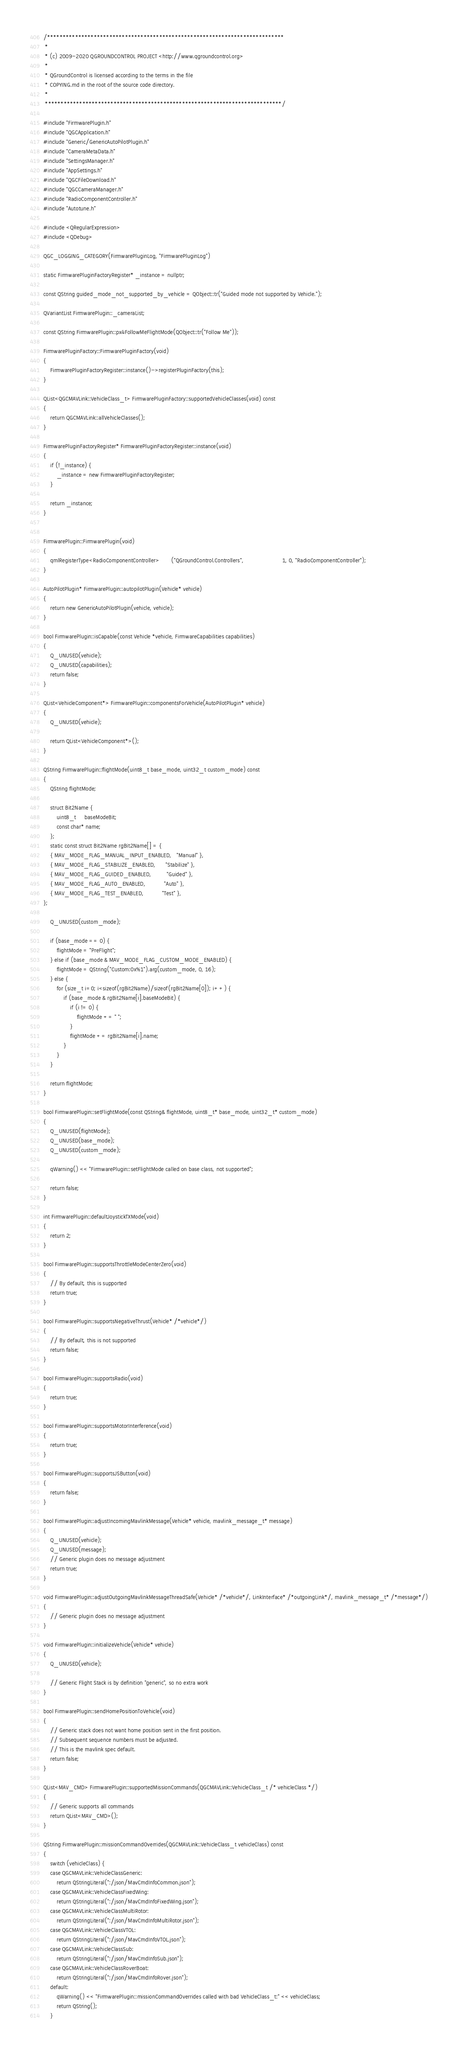Convert code to text. <code><loc_0><loc_0><loc_500><loc_500><_C++_>/****************************************************************************
 *
 * (c) 2009-2020 QGROUNDCONTROL PROJECT <http://www.qgroundcontrol.org>
 *
 * QGroundControl is licensed according to the terms in the file
 * COPYING.md in the root of the source code directory.
 *
 ****************************************************************************/

#include "FirmwarePlugin.h"
#include "QGCApplication.h"
#include "Generic/GenericAutoPilotPlugin.h"
#include "CameraMetaData.h"
#include "SettingsManager.h"
#include "AppSettings.h"
#include "QGCFileDownload.h"
#include "QGCCameraManager.h"
#include "RadioComponentController.h"
#include "Autotune.h"

#include <QRegularExpression>
#include <QDebug>

QGC_LOGGING_CATEGORY(FirmwarePluginLog, "FirmwarePluginLog")

static FirmwarePluginFactoryRegister* _instance = nullptr;

const QString guided_mode_not_supported_by_vehicle = QObject::tr("Guided mode not supported by Vehicle.");

QVariantList FirmwarePlugin::_cameraList;

const QString FirmwarePlugin::px4FollowMeFlightMode(QObject::tr("Follow Me"));

FirmwarePluginFactory::FirmwarePluginFactory(void)
{
    FirmwarePluginFactoryRegister::instance()->registerPluginFactory(this);
}

QList<QGCMAVLink::VehicleClass_t> FirmwarePluginFactory::supportedVehicleClasses(void) const
{
    return QGCMAVLink::allVehicleClasses();
}

FirmwarePluginFactoryRegister* FirmwarePluginFactoryRegister::instance(void)
{
    if (!_instance) {
        _instance = new FirmwarePluginFactoryRegister;
    }

    return _instance;
}


FirmwarePlugin::FirmwarePlugin(void)
{
    qmlRegisterType<RadioComponentController>       ("QGroundControl.Controllers",                       1, 0, "RadioComponentController");
}

AutoPilotPlugin* FirmwarePlugin::autopilotPlugin(Vehicle* vehicle)
{
    return new GenericAutoPilotPlugin(vehicle, vehicle);
}

bool FirmwarePlugin::isCapable(const Vehicle *vehicle, FirmwareCapabilities capabilities)
{
    Q_UNUSED(vehicle);
    Q_UNUSED(capabilities);
    return false;
}

QList<VehicleComponent*> FirmwarePlugin::componentsForVehicle(AutoPilotPlugin* vehicle)
{
    Q_UNUSED(vehicle);

    return QList<VehicleComponent*>();
}

QString FirmwarePlugin::flightMode(uint8_t base_mode, uint32_t custom_mode) const
{
    QString flightMode;

    struct Bit2Name {
        uint8_t     baseModeBit;
        const char* name;
    };
    static const struct Bit2Name rgBit2Name[] = {
    { MAV_MODE_FLAG_MANUAL_INPUT_ENABLED,   "Manual" },
    { MAV_MODE_FLAG_STABILIZE_ENABLED,      "Stabilize" },
    { MAV_MODE_FLAG_GUIDED_ENABLED,         "Guided" },
    { MAV_MODE_FLAG_AUTO_ENABLED,           "Auto" },
    { MAV_MODE_FLAG_TEST_ENABLED,           "Test" },
};

    Q_UNUSED(custom_mode);

    if (base_mode == 0) {
        flightMode = "PreFlight";
    } else if (base_mode & MAV_MODE_FLAG_CUSTOM_MODE_ENABLED) {
        flightMode = QString("Custom:0x%1").arg(custom_mode, 0, 16);
    } else {
        for (size_t i=0; i<sizeof(rgBit2Name)/sizeof(rgBit2Name[0]); i++) {
            if (base_mode & rgBit2Name[i].baseModeBit) {
                if (i != 0) {
                    flightMode += " ";
                }
                flightMode += rgBit2Name[i].name;
            }
        }
    }

    return flightMode;
}

bool FirmwarePlugin::setFlightMode(const QString& flightMode, uint8_t* base_mode, uint32_t* custom_mode)
{
    Q_UNUSED(flightMode);
    Q_UNUSED(base_mode);
    Q_UNUSED(custom_mode);

    qWarning() << "FirmwarePlugin::setFlightMode called on base class, not supported";

    return false;
}

int FirmwarePlugin::defaultJoystickTXMode(void)
{
    return 2;
}

bool FirmwarePlugin::supportsThrottleModeCenterZero(void)
{
    // By default, this is supported
    return true;
}

bool FirmwarePlugin::supportsNegativeThrust(Vehicle* /*vehicle*/)
{
    // By default, this is not supported
    return false;
}

bool FirmwarePlugin::supportsRadio(void)
{
    return true;
}

bool FirmwarePlugin::supportsMotorInterference(void)
{
    return true;
}

bool FirmwarePlugin::supportsJSButton(void)
{
    return false;
}

bool FirmwarePlugin::adjustIncomingMavlinkMessage(Vehicle* vehicle, mavlink_message_t* message)
{
    Q_UNUSED(vehicle);
    Q_UNUSED(message);
    // Generic plugin does no message adjustment
    return true;
}

void FirmwarePlugin::adjustOutgoingMavlinkMessageThreadSafe(Vehicle* /*vehicle*/, LinkInterface* /*outgoingLink*/, mavlink_message_t* /*message*/)
{
    // Generic plugin does no message adjustment
}

void FirmwarePlugin::initializeVehicle(Vehicle* vehicle)
{
    Q_UNUSED(vehicle);

    // Generic Flight Stack is by definition "generic", so no extra work
}

bool FirmwarePlugin::sendHomePositionToVehicle(void)
{
    // Generic stack does not want home position sent in the first position.
    // Subsequent sequence numbers must be adjusted.
    // This is the mavlink spec default.
    return false;
}

QList<MAV_CMD> FirmwarePlugin::supportedMissionCommands(QGCMAVLink::VehicleClass_t /* vehicleClass */)
{
    // Generic supports all commands
    return QList<MAV_CMD>();
}

QString FirmwarePlugin::missionCommandOverrides(QGCMAVLink::VehicleClass_t vehicleClass) const
{
    switch (vehicleClass) {
    case QGCMAVLink::VehicleClassGeneric:
        return QStringLiteral(":/json/MavCmdInfoCommon.json");
    case QGCMAVLink::VehicleClassFixedWing:
        return QStringLiteral(":/json/MavCmdInfoFixedWing.json");
    case QGCMAVLink::VehicleClassMultiRotor:
        return QStringLiteral(":/json/MavCmdInfoMultiRotor.json");
    case QGCMAVLink::VehicleClassVTOL:
        return QStringLiteral(":/json/MavCmdInfoVTOL.json");
    case QGCMAVLink::VehicleClassSub:
        return QStringLiteral(":/json/MavCmdInfoSub.json");
    case QGCMAVLink::VehicleClassRoverBoat:
        return QStringLiteral(":/json/MavCmdInfoRover.json");
    default:
        qWarning() << "FirmwarePlugin::missionCommandOverrides called with bad VehicleClass_t:" << vehicleClass;
        return QString();
    }</code> 